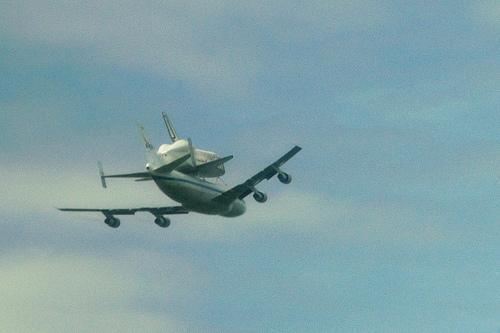How many planes are in the picture?
Give a very brief answer. 2. 